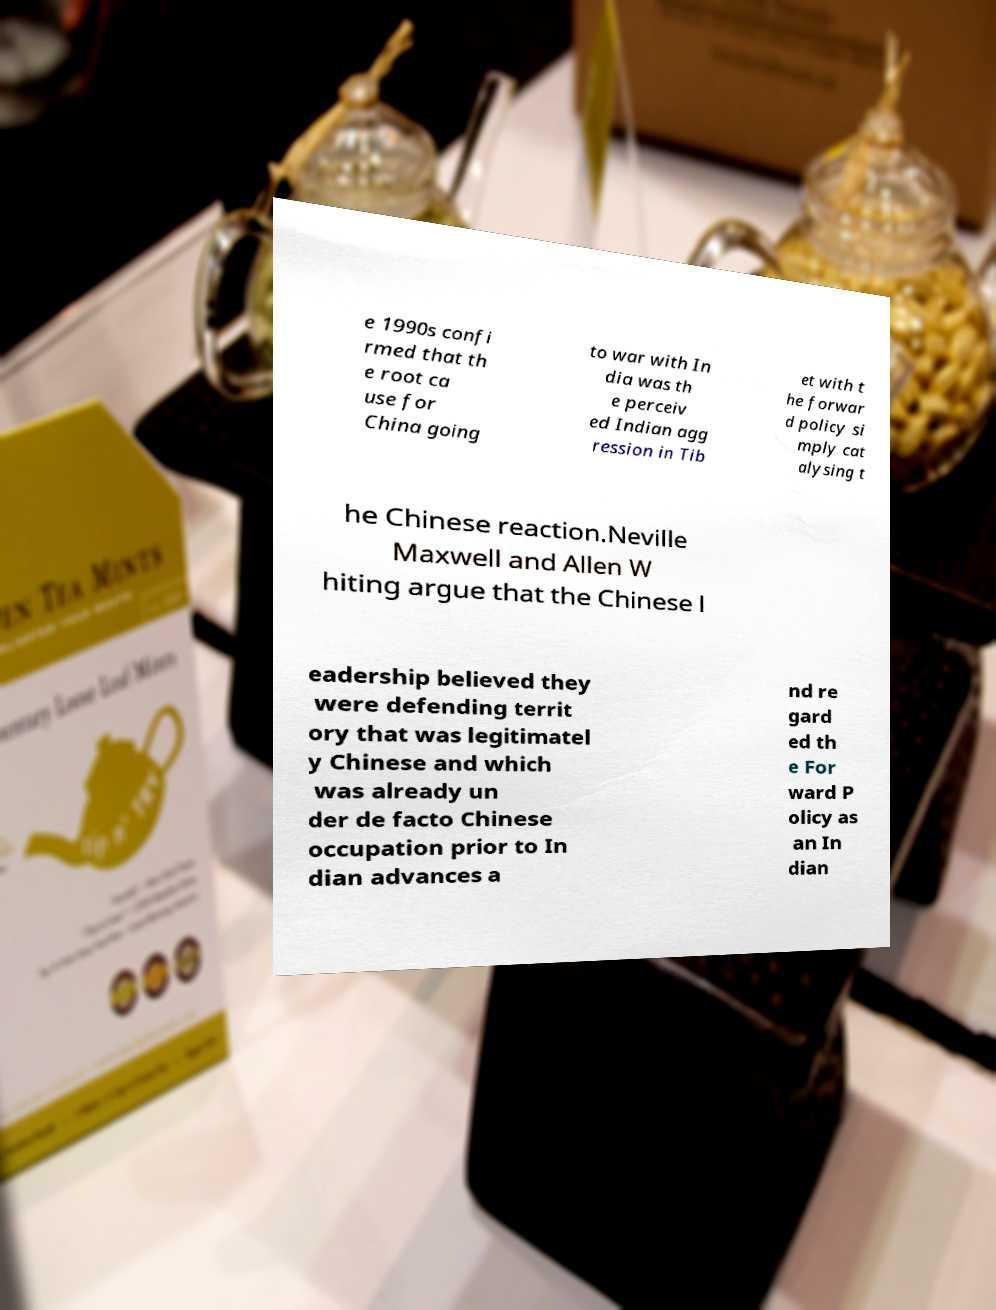Can you accurately transcribe the text from the provided image for me? e 1990s confi rmed that th e root ca use for China going to war with In dia was th e perceiv ed Indian agg ression in Tib et with t he forwar d policy si mply cat alysing t he Chinese reaction.Neville Maxwell and Allen W hiting argue that the Chinese l eadership believed they were defending territ ory that was legitimatel y Chinese and which was already un der de facto Chinese occupation prior to In dian advances a nd re gard ed th e For ward P olicy as an In dian 